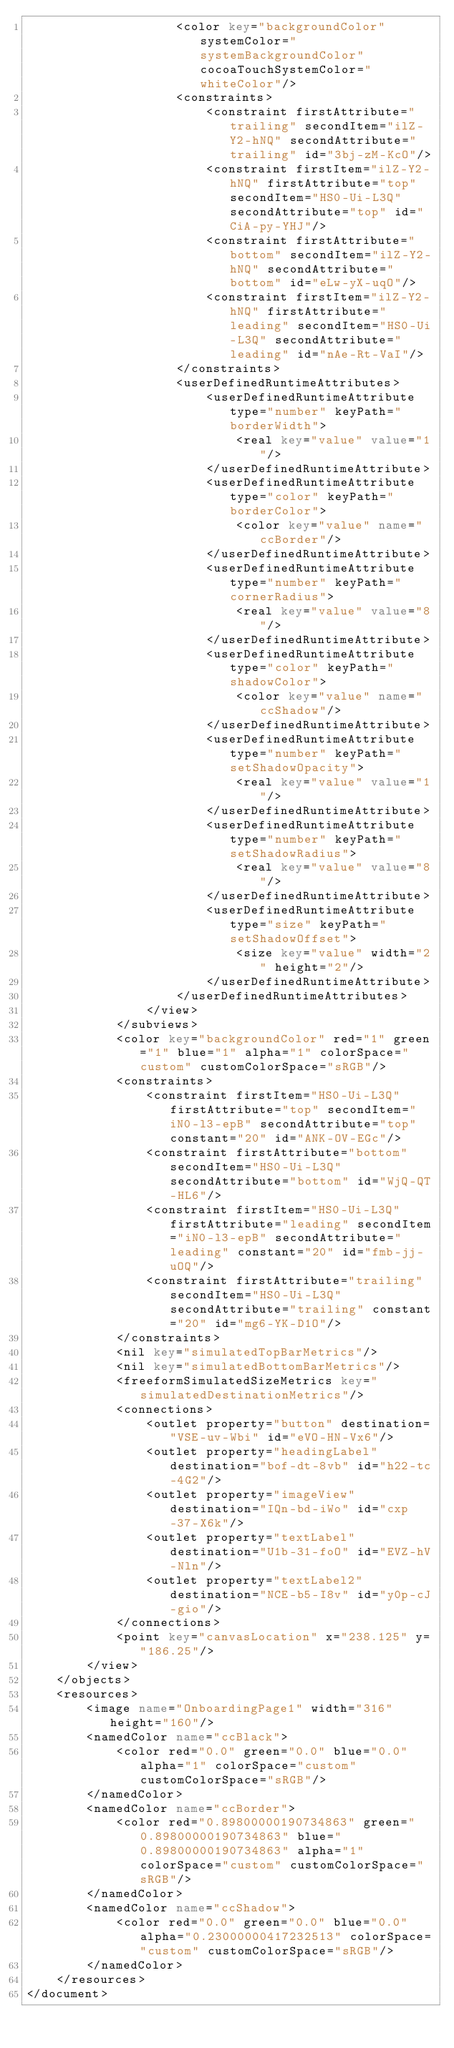Convert code to text. <code><loc_0><loc_0><loc_500><loc_500><_XML_>                    <color key="backgroundColor" systemColor="systemBackgroundColor" cocoaTouchSystemColor="whiteColor"/>
                    <constraints>
                        <constraint firstAttribute="trailing" secondItem="ilZ-Y2-hNQ" secondAttribute="trailing" id="3bj-zM-KcO"/>
                        <constraint firstItem="ilZ-Y2-hNQ" firstAttribute="top" secondItem="HS0-Ui-L3Q" secondAttribute="top" id="CiA-py-YHJ"/>
                        <constraint firstAttribute="bottom" secondItem="ilZ-Y2-hNQ" secondAttribute="bottom" id="eLw-yX-uqO"/>
                        <constraint firstItem="ilZ-Y2-hNQ" firstAttribute="leading" secondItem="HS0-Ui-L3Q" secondAttribute="leading" id="nAe-Rt-VaI"/>
                    </constraints>
                    <userDefinedRuntimeAttributes>
                        <userDefinedRuntimeAttribute type="number" keyPath="borderWidth">
                            <real key="value" value="1"/>
                        </userDefinedRuntimeAttribute>
                        <userDefinedRuntimeAttribute type="color" keyPath="borderColor">
                            <color key="value" name="ccBorder"/>
                        </userDefinedRuntimeAttribute>
                        <userDefinedRuntimeAttribute type="number" keyPath="cornerRadius">
                            <real key="value" value="8"/>
                        </userDefinedRuntimeAttribute>
                        <userDefinedRuntimeAttribute type="color" keyPath="shadowColor">
                            <color key="value" name="ccShadow"/>
                        </userDefinedRuntimeAttribute>
                        <userDefinedRuntimeAttribute type="number" keyPath="setShadowOpacity">
                            <real key="value" value="1"/>
                        </userDefinedRuntimeAttribute>
                        <userDefinedRuntimeAttribute type="number" keyPath="setShadowRadius">
                            <real key="value" value="8"/>
                        </userDefinedRuntimeAttribute>
                        <userDefinedRuntimeAttribute type="size" keyPath="setShadowOffset">
                            <size key="value" width="2" height="2"/>
                        </userDefinedRuntimeAttribute>
                    </userDefinedRuntimeAttributes>
                </view>
            </subviews>
            <color key="backgroundColor" red="1" green="1" blue="1" alpha="1" colorSpace="custom" customColorSpace="sRGB"/>
            <constraints>
                <constraint firstItem="HS0-Ui-L3Q" firstAttribute="top" secondItem="iN0-l3-epB" secondAttribute="top" constant="20" id="ANK-OV-EGc"/>
                <constraint firstAttribute="bottom" secondItem="HS0-Ui-L3Q" secondAttribute="bottom" id="WjQ-QT-HL6"/>
                <constraint firstItem="HS0-Ui-L3Q" firstAttribute="leading" secondItem="iN0-l3-epB" secondAttribute="leading" constant="20" id="fmb-jj-uOQ"/>
                <constraint firstAttribute="trailing" secondItem="HS0-Ui-L3Q" secondAttribute="trailing" constant="20" id="mg6-YK-D1O"/>
            </constraints>
            <nil key="simulatedTopBarMetrics"/>
            <nil key="simulatedBottomBarMetrics"/>
            <freeformSimulatedSizeMetrics key="simulatedDestinationMetrics"/>
            <connections>
                <outlet property="button" destination="VSE-uv-Wbi" id="eVO-HN-Vx6"/>
                <outlet property="headingLabel" destination="bof-dt-8vb" id="h22-tc-4G2"/>
                <outlet property="imageView" destination="IQn-bd-iWo" id="cxp-37-X6k"/>
                <outlet property="textLabel" destination="U1b-31-foO" id="EVZ-hV-Nln"/>
                <outlet property="textLabel2" destination="NCE-b5-I8v" id="y0p-cJ-gio"/>
            </connections>
            <point key="canvasLocation" x="238.125" y="186.25"/>
        </view>
    </objects>
    <resources>
        <image name="OnboardingPage1" width="316" height="160"/>
        <namedColor name="ccBlack">
            <color red="0.0" green="0.0" blue="0.0" alpha="1" colorSpace="custom" customColorSpace="sRGB"/>
        </namedColor>
        <namedColor name="ccBorder">
            <color red="0.89800000190734863" green="0.89800000190734863" blue="0.89800000190734863" alpha="1" colorSpace="custom" customColorSpace="sRGB"/>
        </namedColor>
        <namedColor name="ccShadow">
            <color red="0.0" green="0.0" blue="0.0" alpha="0.23000000417232513" colorSpace="custom" customColorSpace="sRGB"/>
        </namedColor>
    </resources>
</document>
</code> 